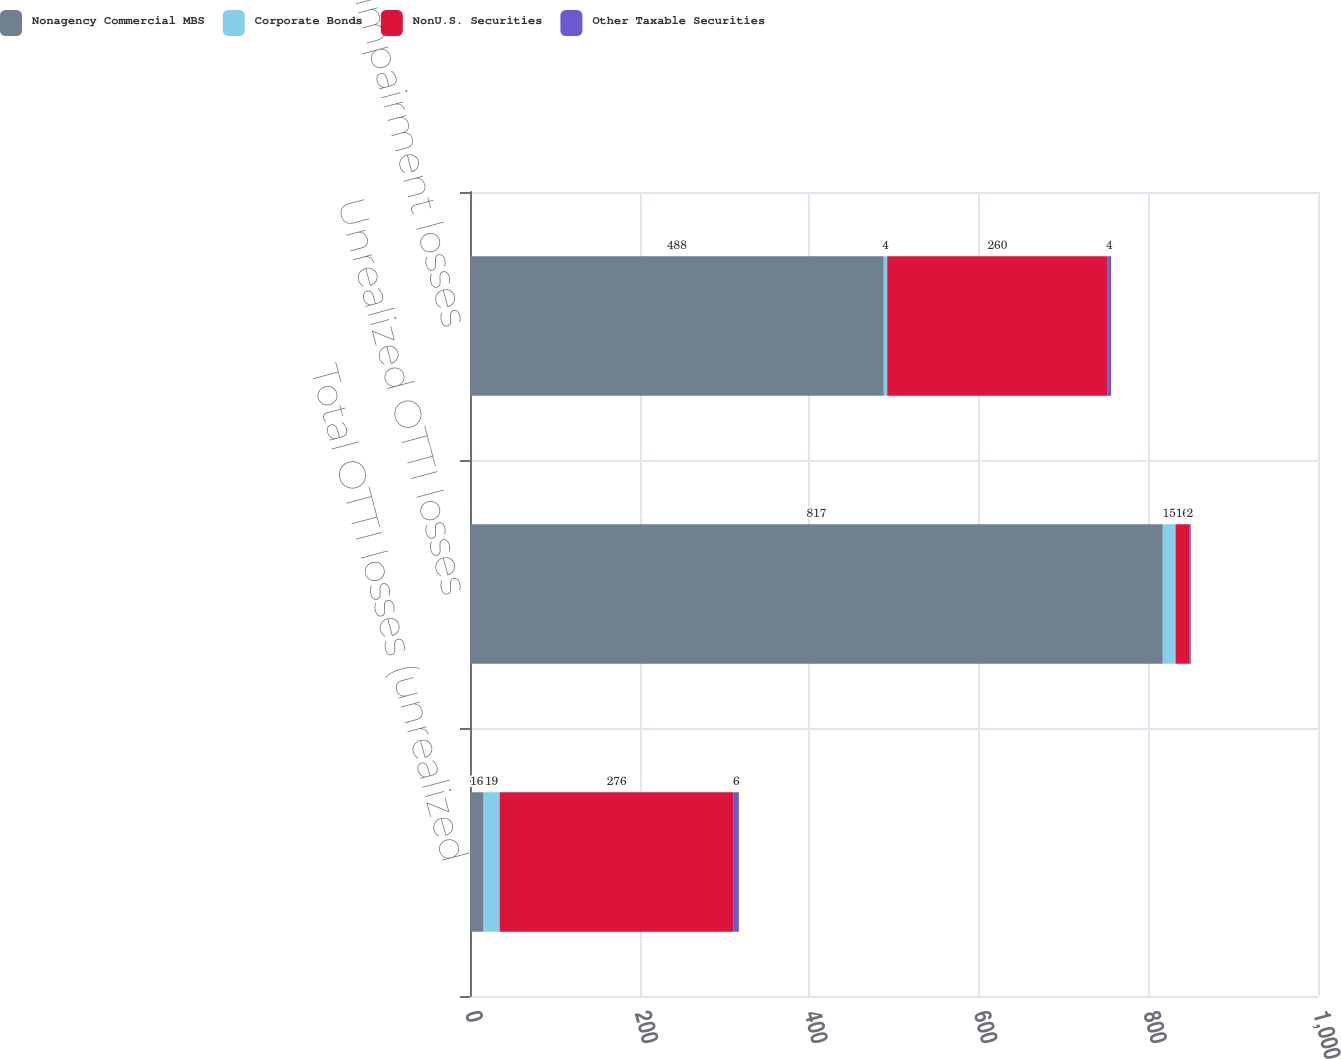<chart> <loc_0><loc_0><loc_500><loc_500><stacked_bar_chart><ecel><fcel>Total OTTI losses (unrealized<fcel>Unrealized OTTI losses<fcel>Net impairment losses<nl><fcel>Nonagency Commercial MBS<fcel>16<fcel>817<fcel>488<nl><fcel>Corporate Bonds<fcel>19<fcel>15<fcel>4<nl><fcel>NonU.S. Securities<fcel>276<fcel>16<fcel>260<nl><fcel>Other Taxable Securities<fcel>6<fcel>2<fcel>4<nl></chart> 